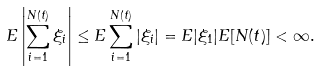<formula> <loc_0><loc_0><loc_500><loc_500>E \left | \sum _ { i = 1 } ^ { N ( t ) } \xi _ { i } \right | \leq E \sum _ { i = 1 } ^ { N ( t ) } | \xi _ { i } | = E | \xi _ { 1 } | E [ N ( t ) ] < \infty .</formula> 